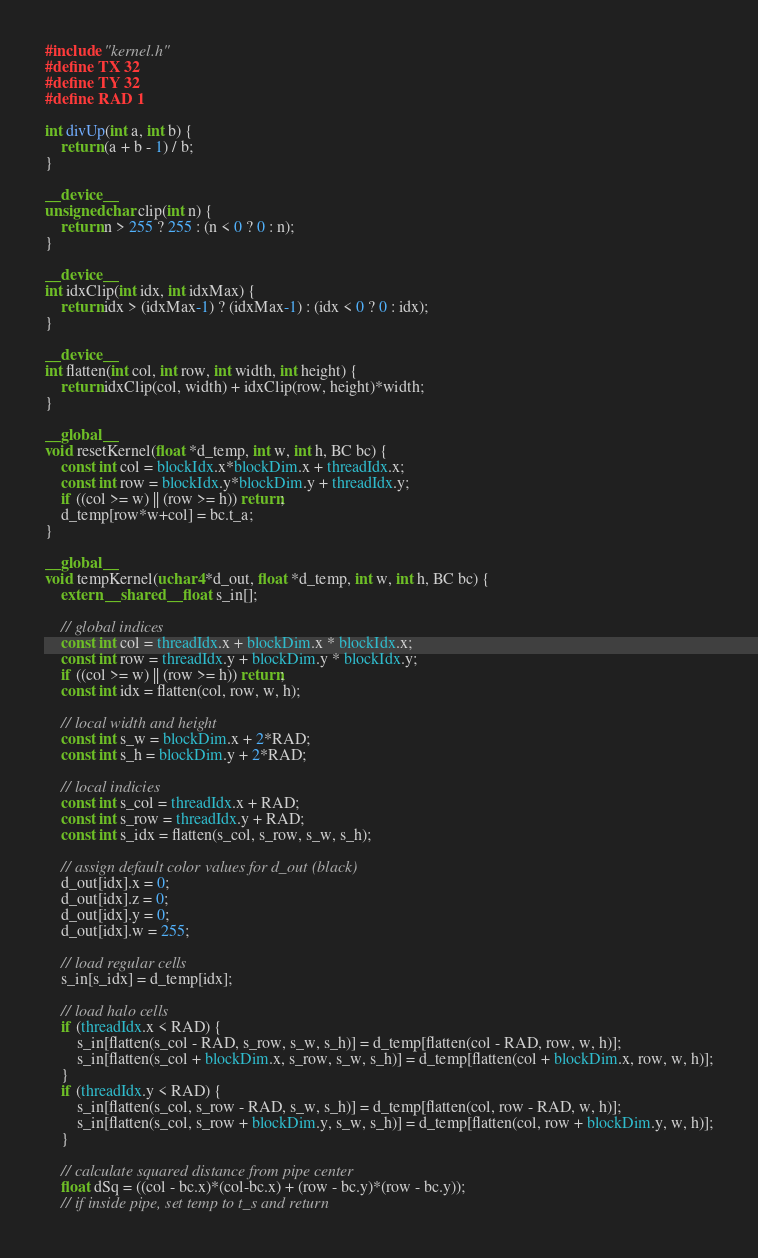<code> <loc_0><loc_0><loc_500><loc_500><_Cuda_>#include "kernel.h"
#define TX 32
#define TY 32
#define RAD 1

int divUp(int a, int b) {
    return (a + b - 1) / b;
}

__device__
unsigned char clip(int n) {
    return n > 255 ? 255 : (n < 0 ? 0 : n);
}

__device__
int idxClip(int idx, int idxMax) {
    return idx > (idxMax-1) ? (idxMax-1) : (idx < 0 ? 0 : idx);
}

__device__
int flatten(int col, int row, int width, int height) {
    return idxClip(col, width) + idxClip(row, height)*width;
}

__global__
void resetKernel(float *d_temp, int w, int h, BC bc) {
    const int col = blockIdx.x*blockDim.x + threadIdx.x;
    const int row = blockIdx.y*blockDim.y + threadIdx.y;
    if ((col >= w) || (row >= h)) return;
    d_temp[row*w+col] = bc.t_a;
}

__global__
void tempKernel(uchar4 *d_out, float *d_temp, int w, int h, BC bc) {
    extern __shared__ float s_in[];

    // global indices
    const int col = threadIdx.x + blockDim.x * blockIdx.x;
    const int row = threadIdx.y + blockDim.y * blockIdx.y;
    if ((col >= w) || (row >= h)) return;
    const int idx = flatten(col, row, w, h);

    // local width and height
    const int s_w = blockDim.x + 2*RAD;
    const int s_h = blockDim.y + 2*RAD;

    // local indicies
    const int s_col = threadIdx.x + RAD;
    const int s_row = threadIdx.y + RAD;
    const int s_idx = flatten(s_col, s_row, s_w, s_h);

    // assign default color values for d_out (black)
    d_out[idx].x = 0;
    d_out[idx].z = 0;
    d_out[idx].y = 0;
    d_out[idx].w = 255;

    // load regular cells
    s_in[s_idx] = d_temp[idx];

    // load halo cells
    if (threadIdx.x < RAD) {
        s_in[flatten(s_col - RAD, s_row, s_w, s_h)] = d_temp[flatten(col - RAD, row, w, h)];
        s_in[flatten(s_col + blockDim.x, s_row, s_w, s_h)] = d_temp[flatten(col + blockDim.x, row, w, h)];
    }
    if (threadIdx.y < RAD) {
        s_in[flatten(s_col, s_row - RAD, s_w, s_h)] = d_temp[flatten(col, row - RAD, w, h)];
        s_in[flatten(s_col, s_row + blockDim.y, s_w, s_h)] = d_temp[flatten(col, row + blockDim.y, w, h)];
    }

    // calculate squared distance from pipe center
    float dSq = ((col - bc.x)*(col-bc.x) + (row - bc.y)*(row - bc.y));
    // if inside pipe, set temp to t_s and return</code> 